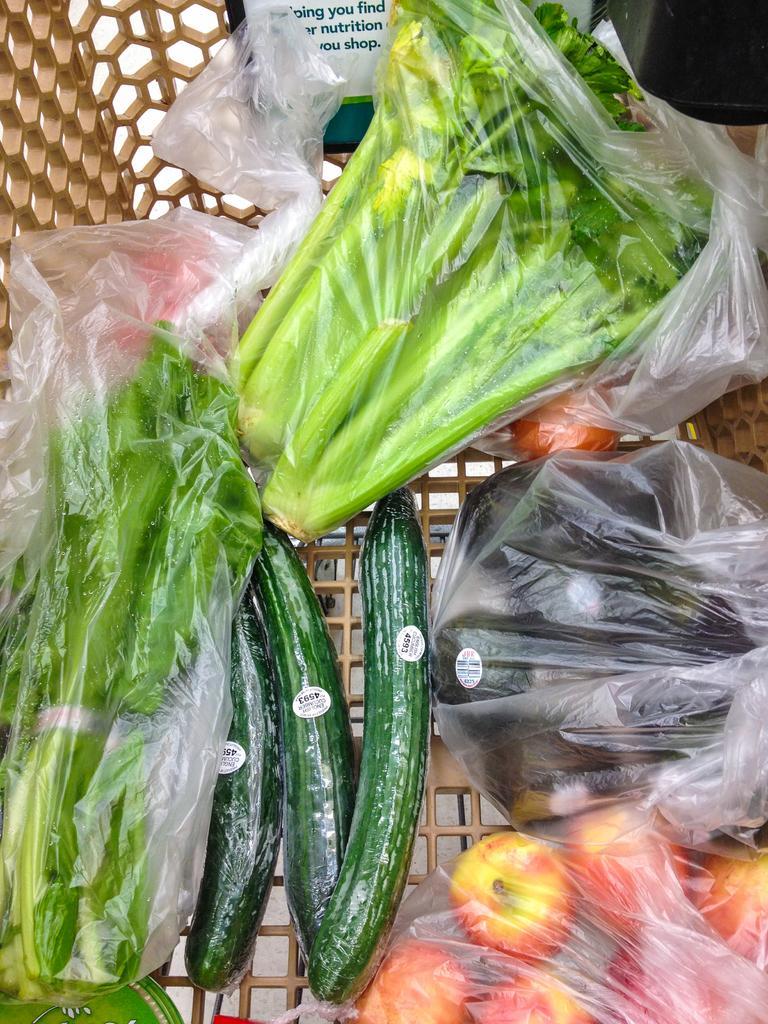Please provide a concise description of this image. In this image we can see vegetables wrapped in a cover, there are tomatoes, cucumbers, in the basket. 